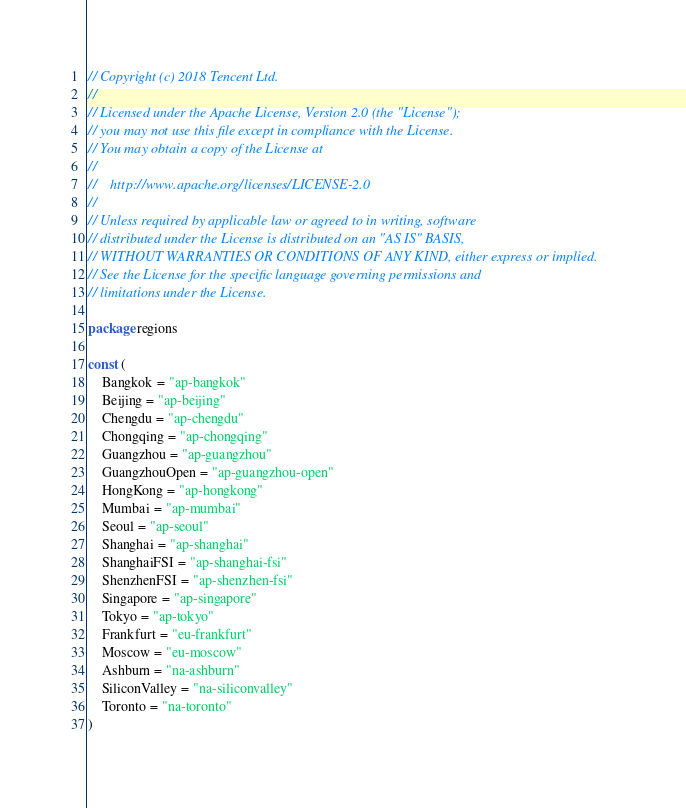Convert code to text. <code><loc_0><loc_0><loc_500><loc_500><_Go_>// Copyright (c) 2018 Tencent Ltd.
//
// Licensed under the Apache License, Version 2.0 (the "License");
// you may not use this file except in compliance with the License.
// You may obtain a copy of the License at
//
//    http://www.apache.org/licenses/LICENSE-2.0
//
// Unless required by applicable law or agreed to in writing, software
// distributed under the License is distributed on an "AS IS" BASIS,
// WITHOUT WARRANTIES OR CONDITIONS OF ANY KIND, either express or implied.
// See the License for the specific language governing permissions and
// limitations under the License.

package regions

const (
	Bangkok = "ap-bangkok"
	Beijing = "ap-beijing"
	Chengdu = "ap-chengdu"
	Chongqing = "ap-chongqing"
	Guangzhou = "ap-guangzhou"
	GuangzhouOpen = "ap-guangzhou-open"
	HongKong = "ap-hongkong"
	Mumbai = "ap-mumbai"
	Seoul = "ap-seoul"
	Shanghai = "ap-shanghai"
	ShanghaiFSI = "ap-shanghai-fsi"
	ShenzhenFSI = "ap-shenzhen-fsi"
	Singapore = "ap-singapore"
	Tokyo = "ap-tokyo"
	Frankfurt = "eu-frankfurt"
	Moscow = "eu-moscow"
	Ashburn = "na-ashburn"
	SiliconValley = "na-siliconvalley"
	Toronto = "na-toronto"
)
</code> 